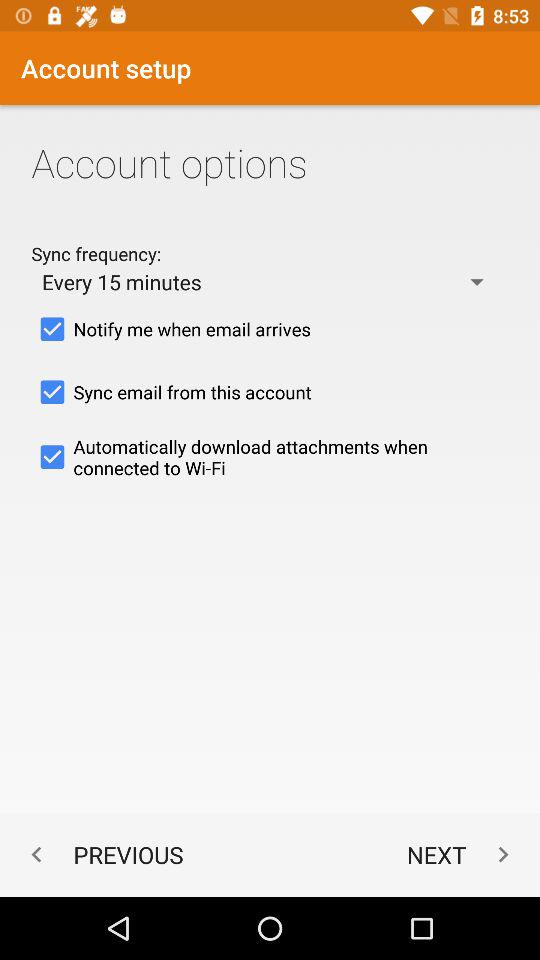What does sync frequency do? Sync frequency "Notify me when email arrives", "Sync email from this account" and "Automatically download attachments when connected to Wi-Fi". 